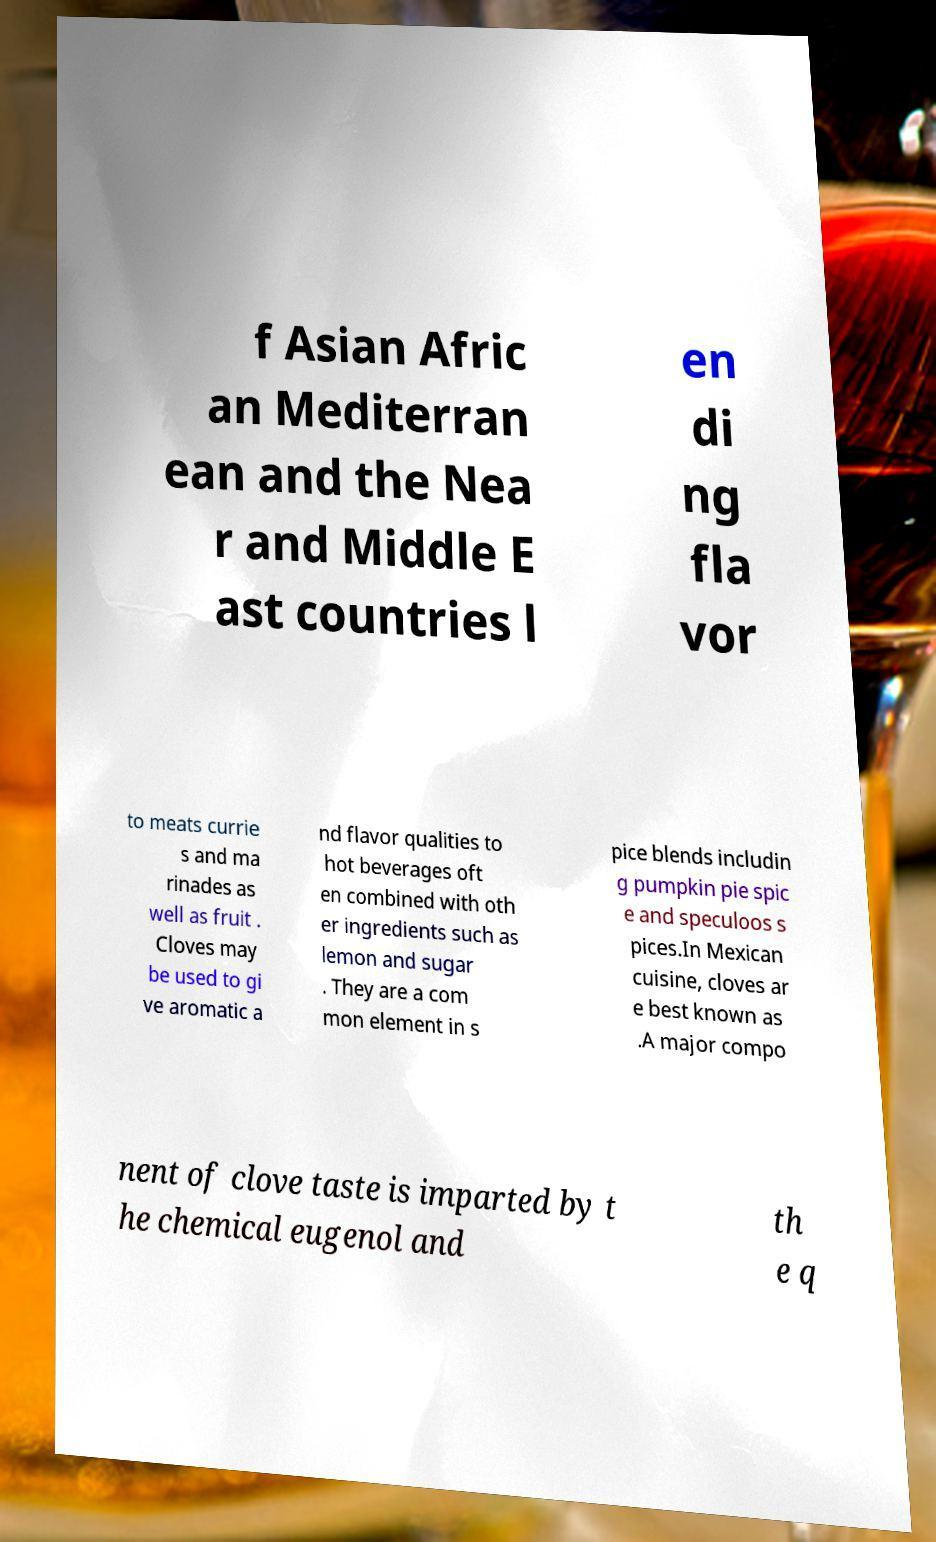Can you read and provide the text displayed in the image?This photo seems to have some interesting text. Can you extract and type it out for me? f Asian Afric an Mediterran ean and the Nea r and Middle E ast countries l en di ng fla vor to meats currie s and ma rinades as well as fruit . Cloves may be used to gi ve aromatic a nd flavor qualities to hot beverages oft en combined with oth er ingredients such as lemon and sugar . They are a com mon element in s pice blends includin g pumpkin pie spic e and speculoos s pices.In Mexican cuisine, cloves ar e best known as .A major compo nent of clove taste is imparted by t he chemical eugenol and th e q 